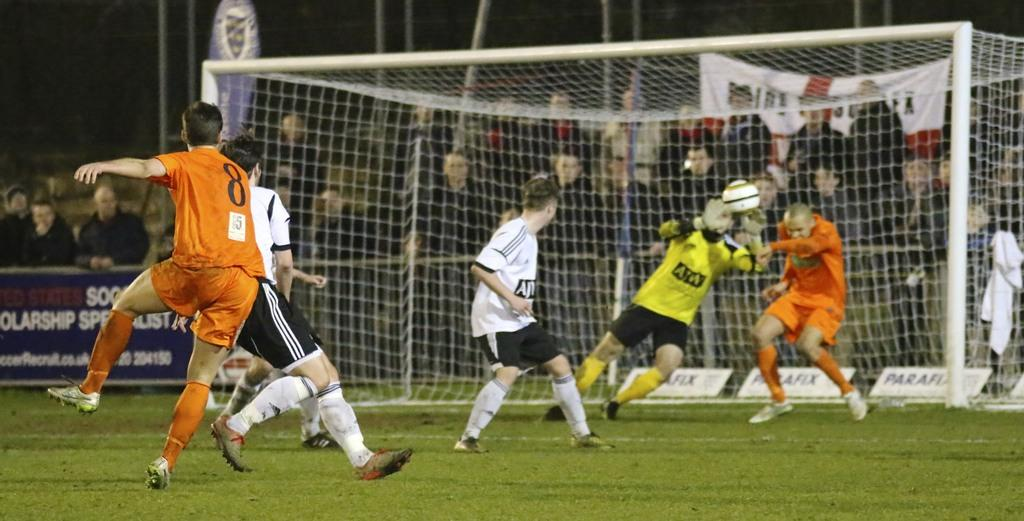<image>
Relay a brief, clear account of the picture shown. Player number 8 on the orange team is jumping up in the air. 